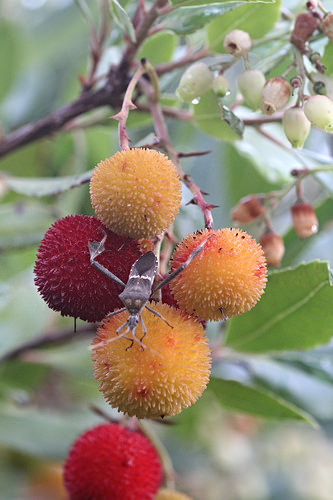<image>
Is there a insect under the fruit? No. The insect is not positioned under the fruit. The vertical relationship between these objects is different. Is the bug in front of the leaf? Yes. The bug is positioned in front of the leaf, appearing closer to the camera viewpoint. 